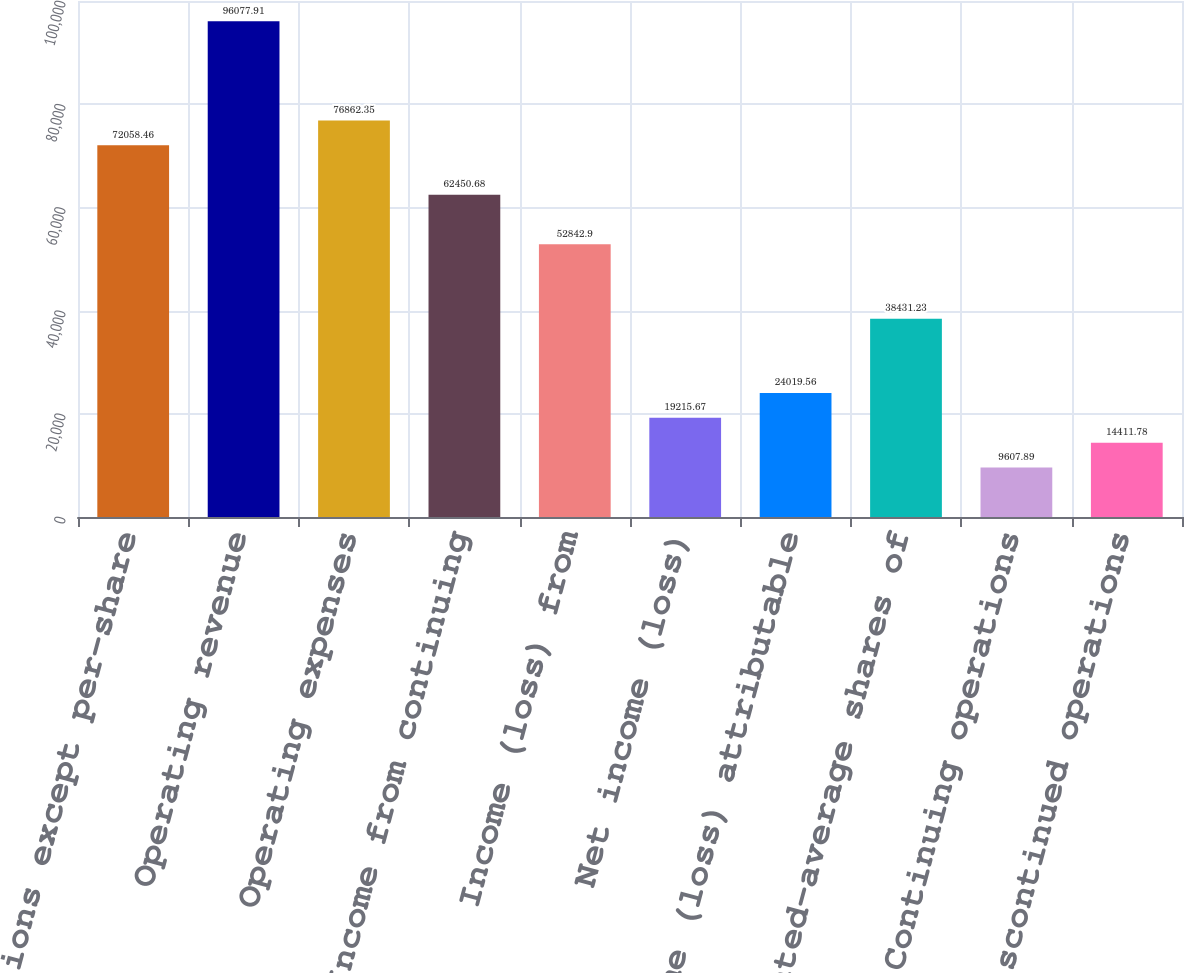Convert chart. <chart><loc_0><loc_0><loc_500><loc_500><bar_chart><fcel>(in millions except per-share<fcel>Operating revenue<fcel>Operating expenses<fcel>Income from continuing<fcel>Income (loss) from<fcel>Net income (loss)<fcel>Net income (loss) attributable<fcel>Weighted-average shares of<fcel>Continuing operations<fcel>Discontinued operations<nl><fcel>72058.5<fcel>96077.9<fcel>76862.4<fcel>62450.7<fcel>52842.9<fcel>19215.7<fcel>24019.6<fcel>38431.2<fcel>9607.89<fcel>14411.8<nl></chart> 